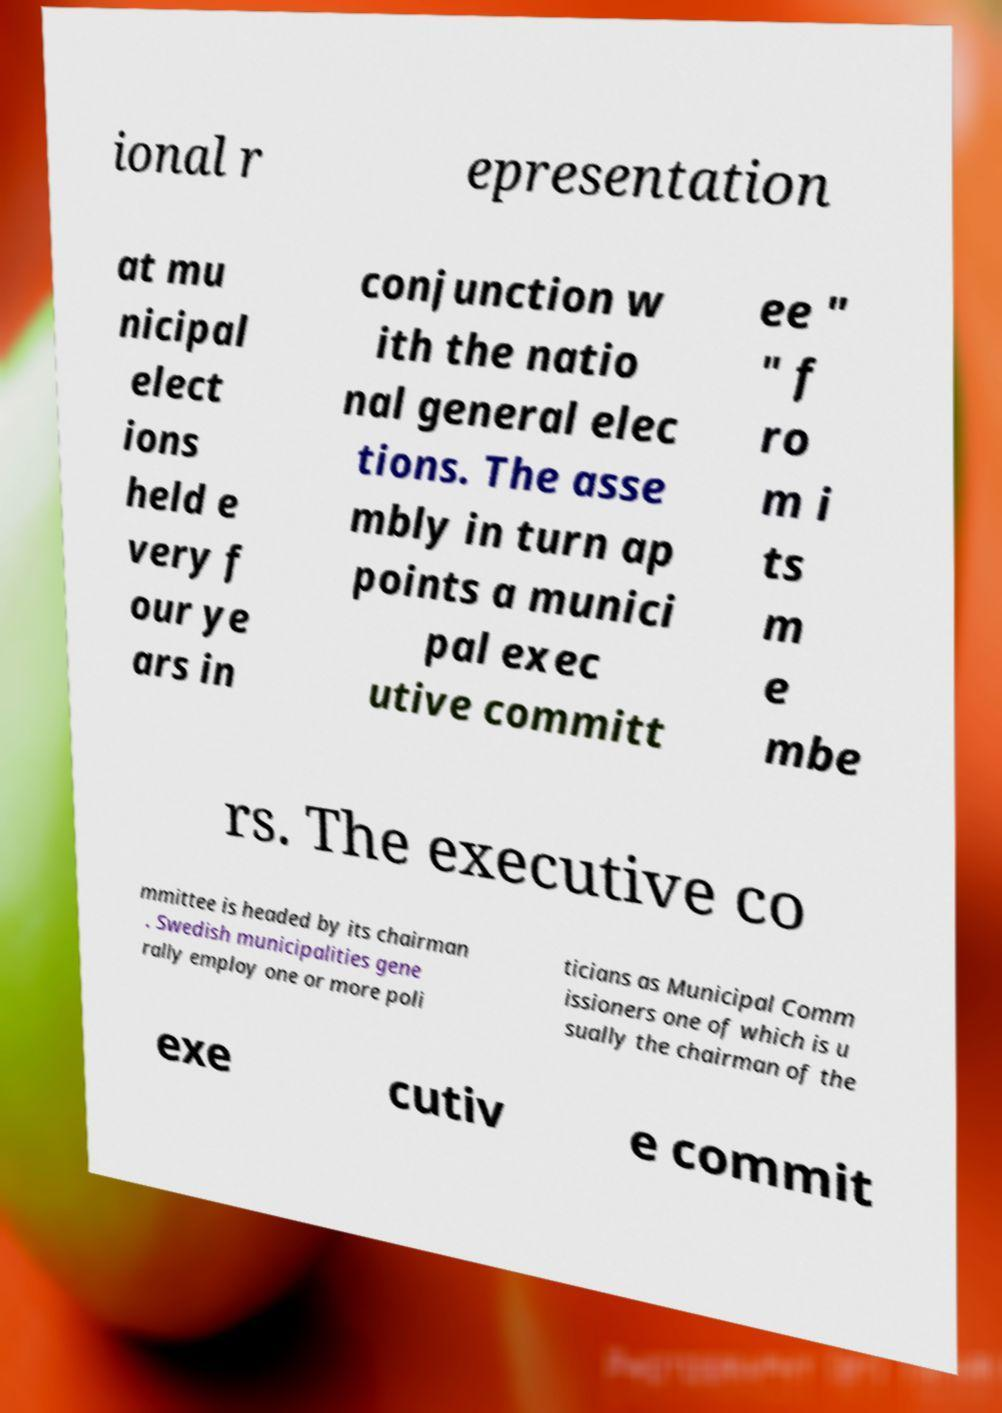Could you extract and type out the text from this image? ional r epresentation at mu nicipal elect ions held e very f our ye ars in conjunction w ith the natio nal general elec tions. The asse mbly in turn ap points a munici pal exec utive committ ee " " f ro m i ts m e mbe rs. The executive co mmittee is headed by its chairman . Swedish municipalities gene rally employ one or more poli ticians as Municipal Comm issioners one of which is u sually the chairman of the exe cutiv e commit 